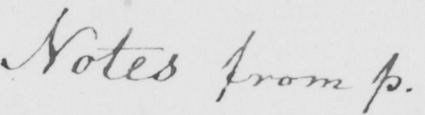What is written in this line of handwriting? Note from p . 